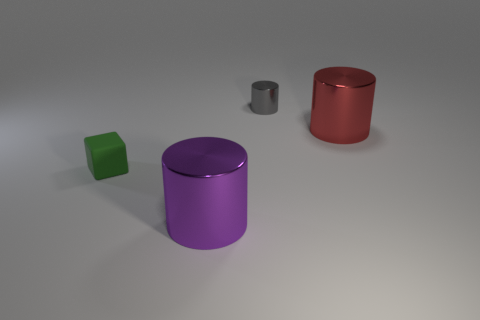How many large cylinders are left of the big metal cylinder behind the big thing that is in front of the small rubber cube?
Keep it short and to the point. 1. What is the color of the large thing that is in front of the cylinder that is to the right of the gray thing?
Offer a terse response. Purple. There is a big cylinder in front of the large red metallic thing; how many small metallic objects are behind it?
Offer a terse response. 1. There is a big metallic cylinder that is on the left side of the gray metallic thing; is it the same color as the large object that is behind the small green matte object?
Ensure brevity in your answer.  No. There is a tiny thing that is on the right side of the tiny object in front of the tiny gray thing; what is its shape?
Offer a very short reply. Cylinder. Is there anything else that has the same size as the purple object?
Your answer should be very brief. Yes. What is the shape of the object that is behind the big metallic thing that is behind the tiny rubber block that is to the left of the gray cylinder?
Make the answer very short. Cylinder. What number of things are big shiny cylinders that are on the right side of the tiny metal cylinder or big shiny objects on the right side of the purple object?
Your answer should be compact. 1. Is the size of the green block the same as the cylinder in front of the small cube?
Offer a very short reply. No. Is the tiny object that is behind the green matte thing made of the same material as the big cylinder behind the tiny green object?
Ensure brevity in your answer.  Yes. 